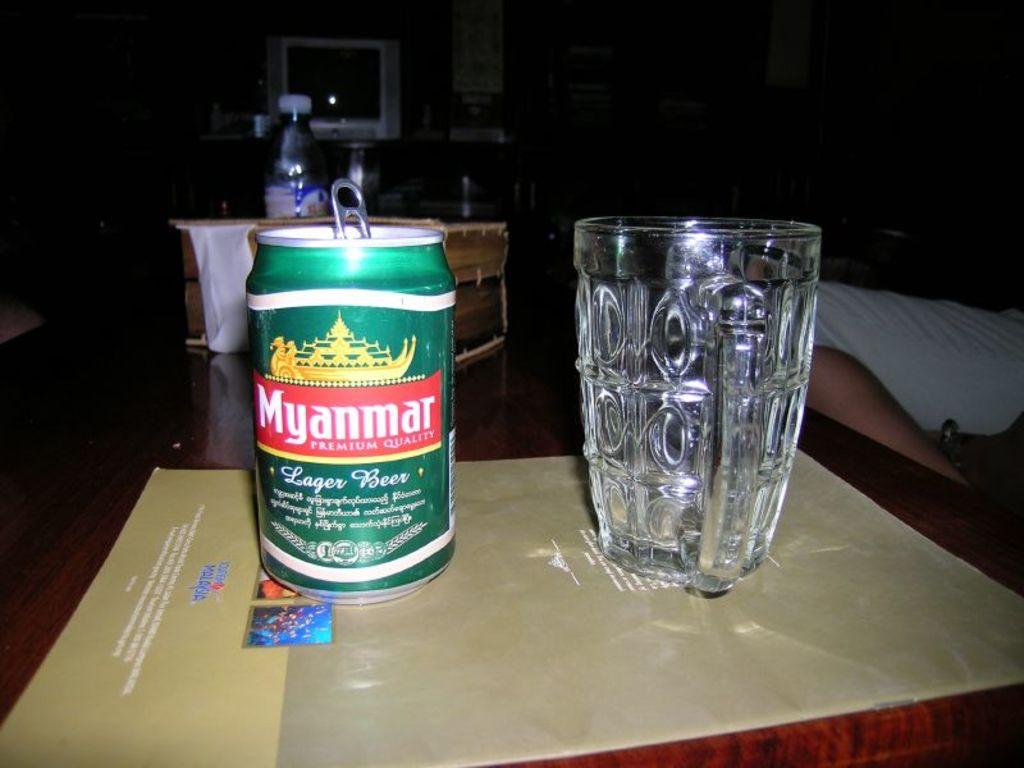<image>
Render a clear and concise summary of the photo. The glass that is next to the can of Myanmar beer has oval dimples on the sides. 